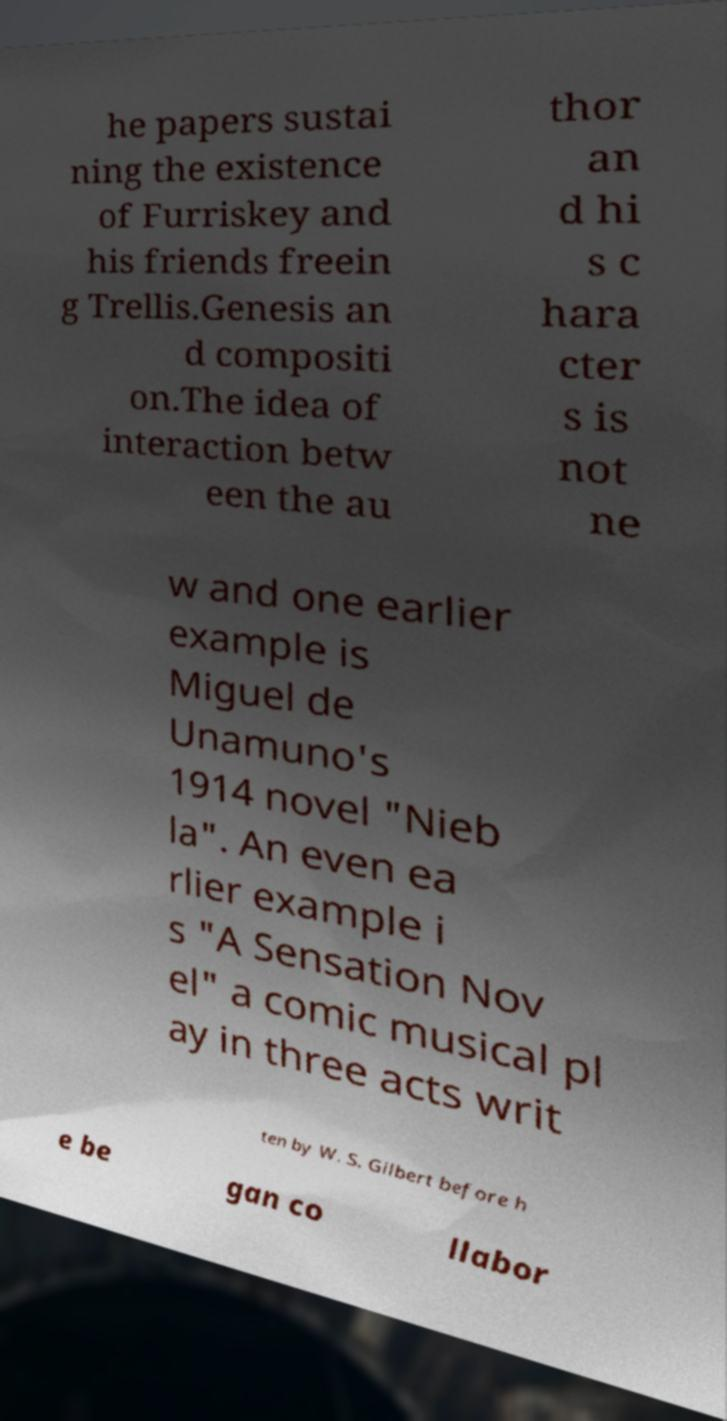What messages or text are displayed in this image? I need them in a readable, typed format. he papers sustai ning the existence of Furriskey and his friends freein g Trellis.Genesis an d compositi on.The idea of interaction betw een the au thor an d hi s c hara cter s is not ne w and one earlier example is Miguel de Unamuno's 1914 novel "Nieb la". An even ea rlier example i s "A Sensation Nov el" a comic musical pl ay in three acts writ ten by W. S. Gilbert before h e be gan co llabor 